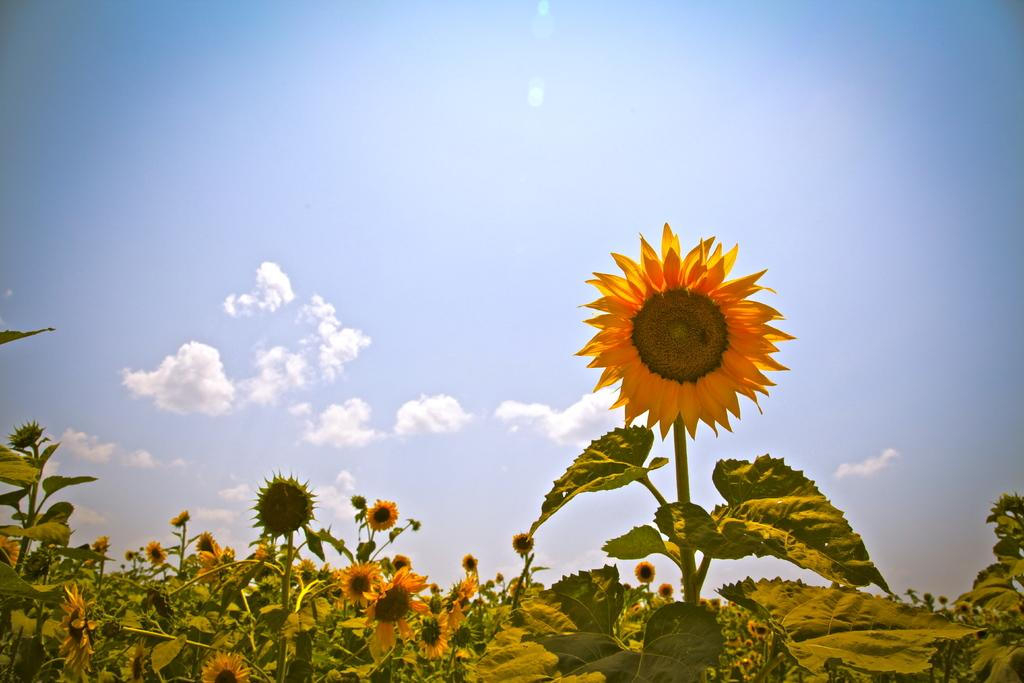What type of flowers are on the plants in the image? There are sunflowers on the plants in the image. What can be seen in the background of the image? The sky is visible in the background of the image. What is the condition of the sky in the image? There are clouds in the sky in the image. What type of house can be seen in the image? There is no house present in the image; it features sunflowers and a cloudy sky. What kind of brush is used to paint the sunflowers in the image? There is no brush or painting present in the image; it is a photograph of real sunflowers and a sky with clouds. 